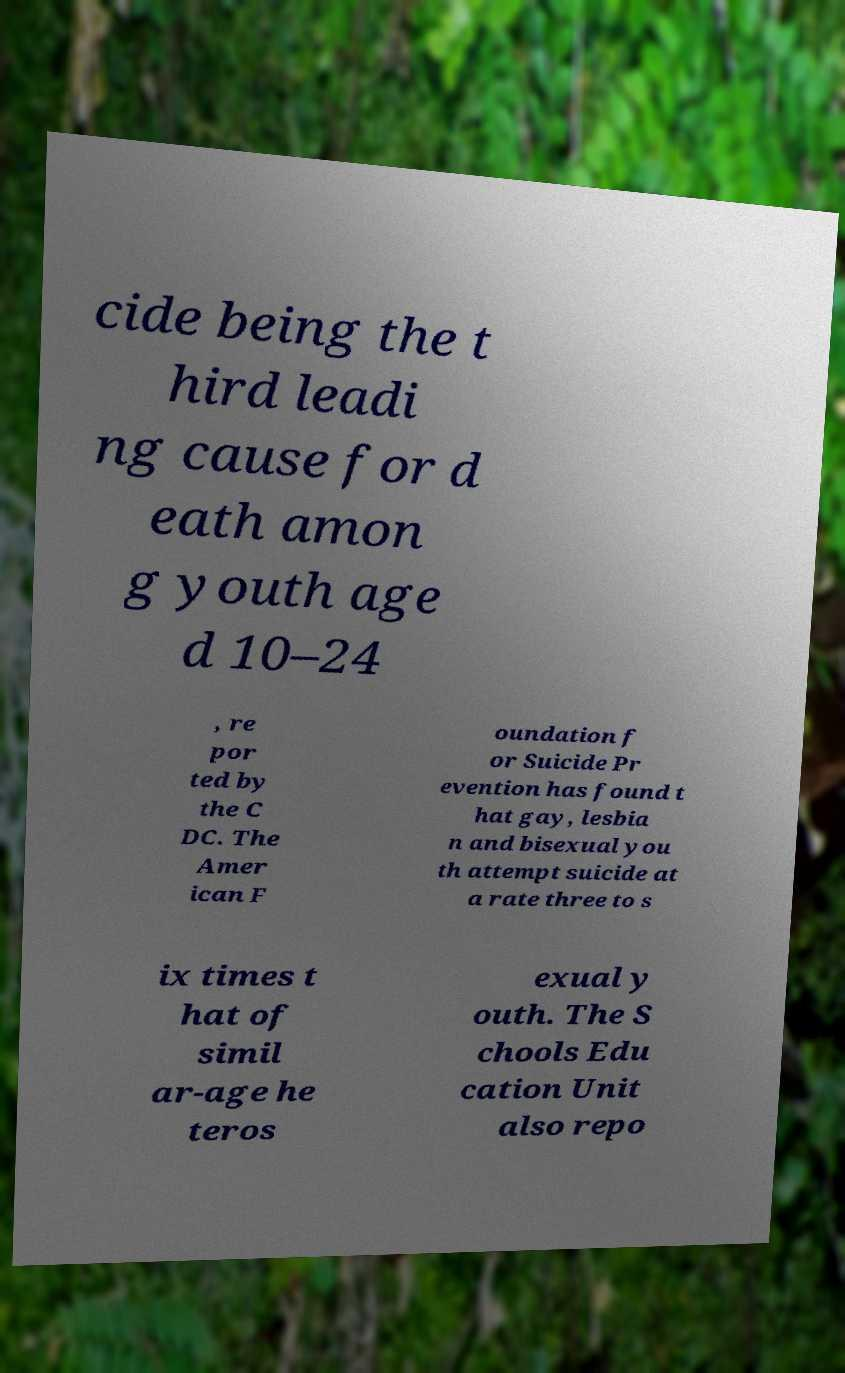Can you read and provide the text displayed in the image?This photo seems to have some interesting text. Can you extract and type it out for me? cide being the t hird leadi ng cause for d eath amon g youth age d 10–24 , re por ted by the C DC. The Amer ican F oundation f or Suicide Pr evention has found t hat gay, lesbia n and bisexual you th attempt suicide at a rate three to s ix times t hat of simil ar-age he teros exual y outh. The S chools Edu cation Unit also repo 